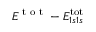Convert formula to latex. <formula><loc_0><loc_0><loc_500><loc_500>E ^ { t o t } - E _ { 1 s 1 s } ^ { t o t }</formula> 